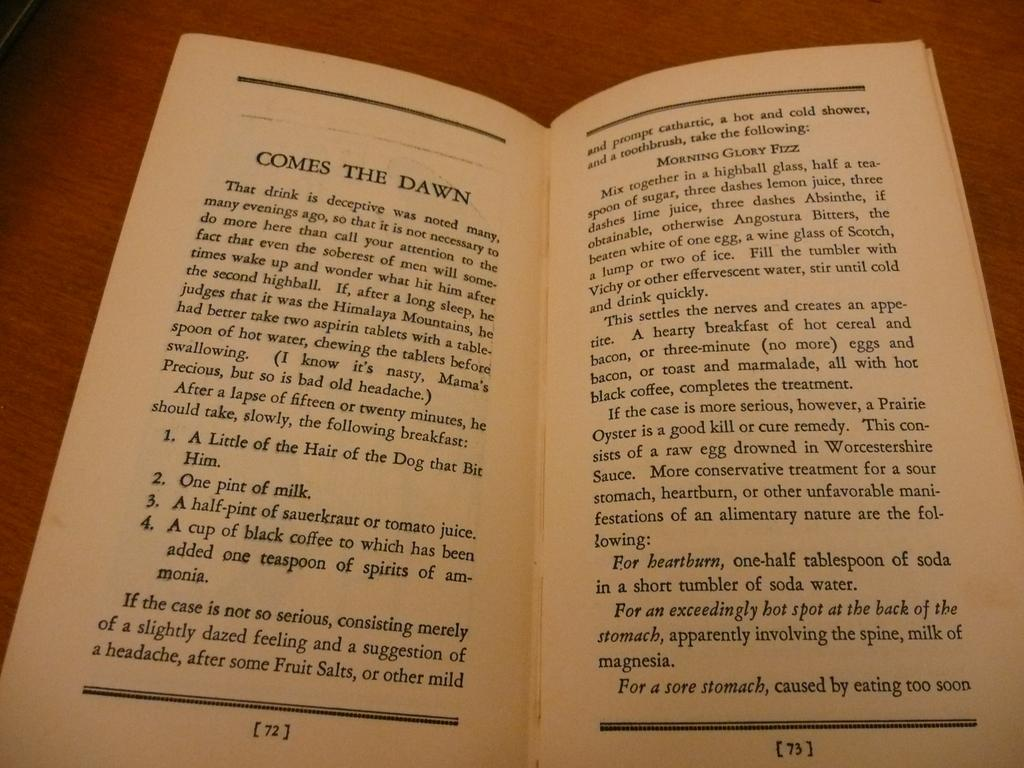Provide a one-sentence caption for the provided image. A book on a brown talbe, lies open to pages 72-73 for the chapter titled, Comes The Dawn. 